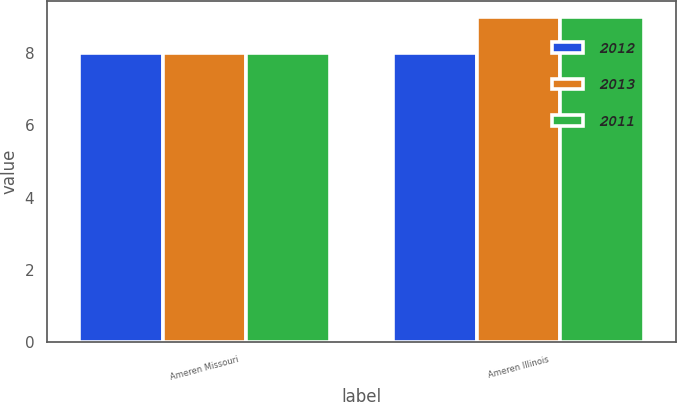Convert chart. <chart><loc_0><loc_0><loc_500><loc_500><stacked_bar_chart><ecel><fcel>Ameren Missouri<fcel>Ameren Illinois<nl><fcel>2012<fcel>8<fcel>8<nl><fcel>2013<fcel>8<fcel>9<nl><fcel>2011<fcel>8<fcel>9<nl></chart> 